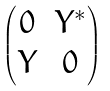Convert formula to latex. <formula><loc_0><loc_0><loc_500><loc_500>\begin{pmatrix} 0 & Y ^ { * } \\ Y & 0 \end{pmatrix}</formula> 